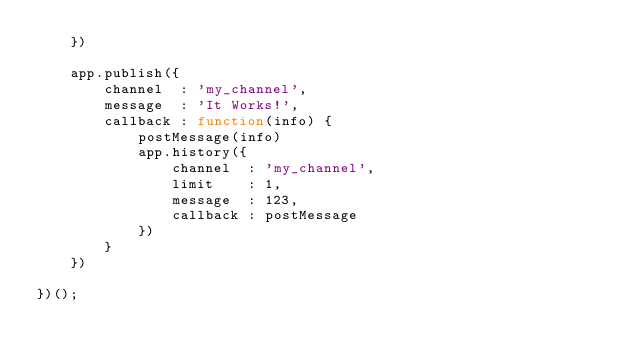<code> <loc_0><loc_0><loc_500><loc_500><_JavaScript_>    })

    app.publish({
        channel  : 'my_channel',
        message  : 'It Works!',
        callback : function(info) {
            postMessage(info)
            app.history({
                channel  : 'my_channel',
                limit    : 1,
                message  : 123,
                callback : postMessage
            })
        }
    })

})();
</code> 